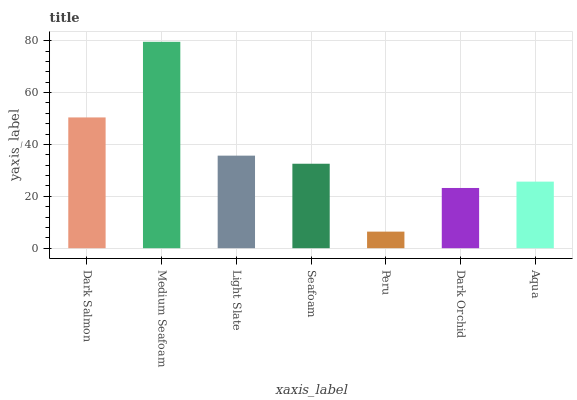Is Peru the minimum?
Answer yes or no. Yes. Is Medium Seafoam the maximum?
Answer yes or no. Yes. Is Light Slate the minimum?
Answer yes or no. No. Is Light Slate the maximum?
Answer yes or no. No. Is Medium Seafoam greater than Light Slate?
Answer yes or no. Yes. Is Light Slate less than Medium Seafoam?
Answer yes or no. Yes. Is Light Slate greater than Medium Seafoam?
Answer yes or no. No. Is Medium Seafoam less than Light Slate?
Answer yes or no. No. Is Seafoam the high median?
Answer yes or no. Yes. Is Seafoam the low median?
Answer yes or no. Yes. Is Dark Salmon the high median?
Answer yes or no. No. Is Dark Orchid the low median?
Answer yes or no. No. 